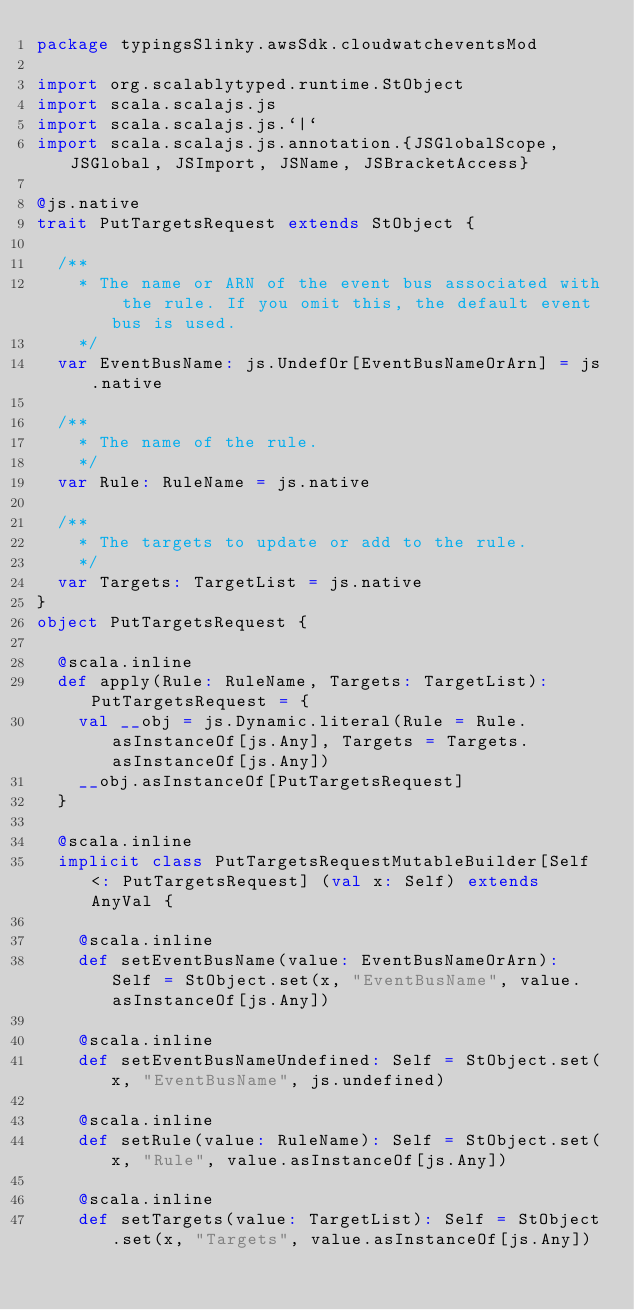<code> <loc_0><loc_0><loc_500><loc_500><_Scala_>package typingsSlinky.awsSdk.cloudwatcheventsMod

import org.scalablytyped.runtime.StObject
import scala.scalajs.js
import scala.scalajs.js.`|`
import scala.scalajs.js.annotation.{JSGlobalScope, JSGlobal, JSImport, JSName, JSBracketAccess}

@js.native
trait PutTargetsRequest extends StObject {
  
  /**
    * The name or ARN of the event bus associated with the rule. If you omit this, the default event bus is used.
    */
  var EventBusName: js.UndefOr[EventBusNameOrArn] = js.native
  
  /**
    * The name of the rule.
    */
  var Rule: RuleName = js.native
  
  /**
    * The targets to update or add to the rule.
    */
  var Targets: TargetList = js.native
}
object PutTargetsRequest {
  
  @scala.inline
  def apply(Rule: RuleName, Targets: TargetList): PutTargetsRequest = {
    val __obj = js.Dynamic.literal(Rule = Rule.asInstanceOf[js.Any], Targets = Targets.asInstanceOf[js.Any])
    __obj.asInstanceOf[PutTargetsRequest]
  }
  
  @scala.inline
  implicit class PutTargetsRequestMutableBuilder[Self <: PutTargetsRequest] (val x: Self) extends AnyVal {
    
    @scala.inline
    def setEventBusName(value: EventBusNameOrArn): Self = StObject.set(x, "EventBusName", value.asInstanceOf[js.Any])
    
    @scala.inline
    def setEventBusNameUndefined: Self = StObject.set(x, "EventBusName", js.undefined)
    
    @scala.inline
    def setRule(value: RuleName): Self = StObject.set(x, "Rule", value.asInstanceOf[js.Any])
    
    @scala.inline
    def setTargets(value: TargetList): Self = StObject.set(x, "Targets", value.asInstanceOf[js.Any])
    </code> 